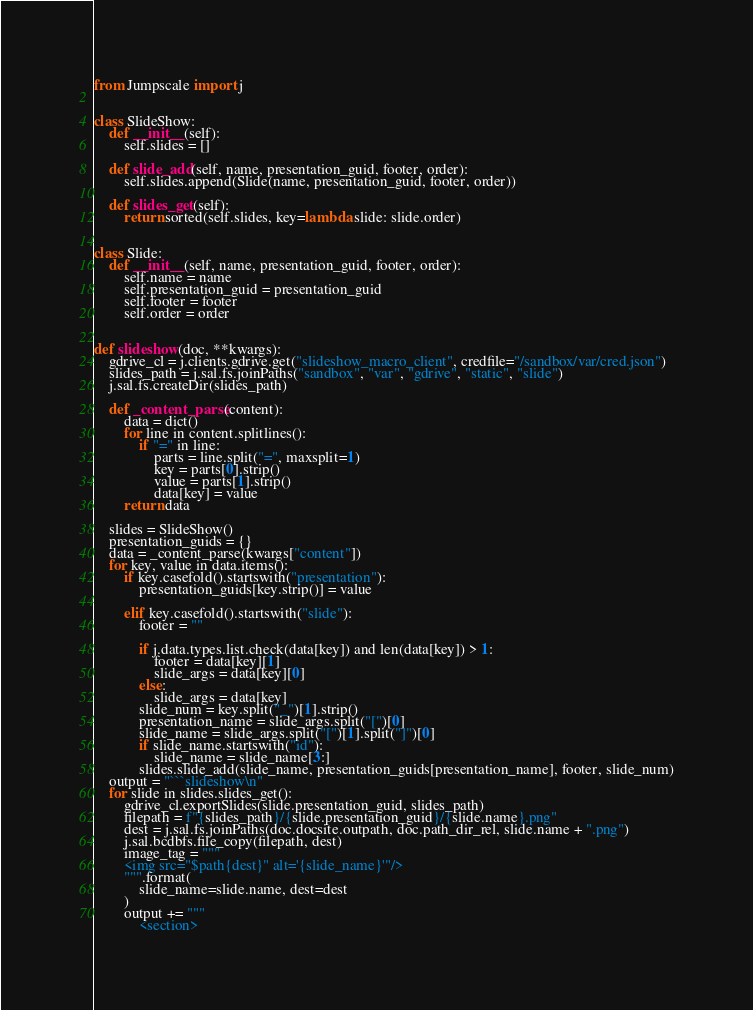<code> <loc_0><loc_0><loc_500><loc_500><_Python_>from Jumpscale import j


class SlideShow:
    def __init__(self):
        self.slides = []

    def slide_add(self, name, presentation_guid, footer, order):
        self.slides.append(Slide(name, presentation_guid, footer, order))

    def slides_get(self):
        return sorted(self.slides, key=lambda slide: slide.order)


class Slide:
    def __init__(self, name, presentation_guid, footer, order):
        self.name = name
        self.presentation_guid = presentation_guid
        self.footer = footer
        self.order = order


def slideshow(doc, **kwargs):
    gdrive_cl = j.clients.gdrive.get("slideshow_macro_client", credfile="/sandbox/var/cred.json")
    slides_path = j.sal.fs.joinPaths("sandbox", "var", "gdrive", "static", "slide")
    j.sal.fs.createDir(slides_path)

    def _content_parse(content):
        data = dict()
        for line in content.splitlines():
            if "=" in line:
                parts = line.split("=", maxsplit=1)
                key = parts[0].strip()
                value = parts[1].strip()
                data[key] = value
        return data

    slides = SlideShow()
    presentation_guids = {}
    data = _content_parse(kwargs["content"])
    for key, value in data.items():
        if key.casefold().startswith("presentation"):
            presentation_guids[key.strip()] = value

        elif key.casefold().startswith("slide"):
            footer = ""

            if j.data.types.list.check(data[key]) and len(data[key]) > 1:
                footer = data[key][1]
                slide_args = data[key][0]
            else:
                slide_args = data[key]
            slide_num = key.split("_")[1].strip()
            presentation_name = slide_args.split("[")[0]
            slide_name = slide_args.split("[")[1].split("]")[0]
            if slide_name.startswith("id"):
                slide_name = slide_name[3:]
            slides.slide_add(slide_name, presentation_guids[presentation_name], footer, slide_num)
    output = "```slideshow\n"
    for slide in slides.slides_get():
        gdrive_cl.exportSlides(slide.presentation_guid, slides_path)
        filepath = f"{slides_path}/{slide.presentation_guid}/{slide.name}.png"
        dest = j.sal.fs.joinPaths(doc.docsite.outpath, doc.path_dir_rel, slide.name + ".png")
        j.sal.bcdbfs.file_copy(filepath, dest)
        image_tag = """
        <img src="$path{dest}" alt='{slide_name}'"/>
        """.format(
            slide_name=slide.name, dest=dest
        )
        output += """
            <section></code> 